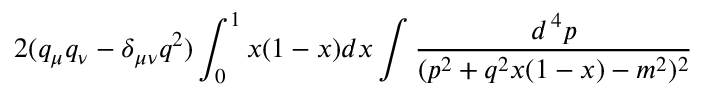Convert formula to latex. <formula><loc_0><loc_0><loc_500><loc_500>2 ( q _ { \mu } q _ { \nu } - \delta _ { \mu \nu } q ^ { 2 } ) \int _ { 0 } ^ { 1 } x ( 1 - x ) d x \int { \frac { d ^ { \, 4 } p } { ( p ^ { 2 } + q ^ { 2 } x ( 1 - x ) - m ^ { 2 } ) ^ { 2 } } }</formula> 